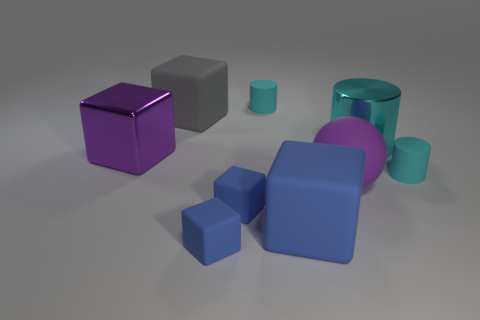The big ball that is made of the same material as the gray block is what color?
Your response must be concise. Purple. Does the tiny cyan thing to the left of the ball have the same shape as the large cyan object?
Make the answer very short. Yes. What number of things are matte cubes in front of the gray rubber block or rubber things that are behind the purple shiny block?
Offer a very short reply. 5. What is the color of the big metal thing that is the same shape as the large blue rubber thing?
Give a very brief answer. Purple. Is there any other thing that is the same shape as the purple matte object?
Provide a short and direct response. No. There is a gray matte object; is it the same shape as the thing to the left of the gray thing?
Give a very brief answer. Yes. What is the material of the sphere?
Provide a short and direct response. Rubber. What number of other things are the same material as the large cyan cylinder?
Provide a succinct answer. 1. Do the big purple sphere and the large cyan cylinder that is behind the purple metallic block have the same material?
Your answer should be compact. No. Is the number of large purple balls that are to the right of the large cyan thing less than the number of cyan shiny objects that are behind the purple rubber thing?
Ensure brevity in your answer.  Yes. 